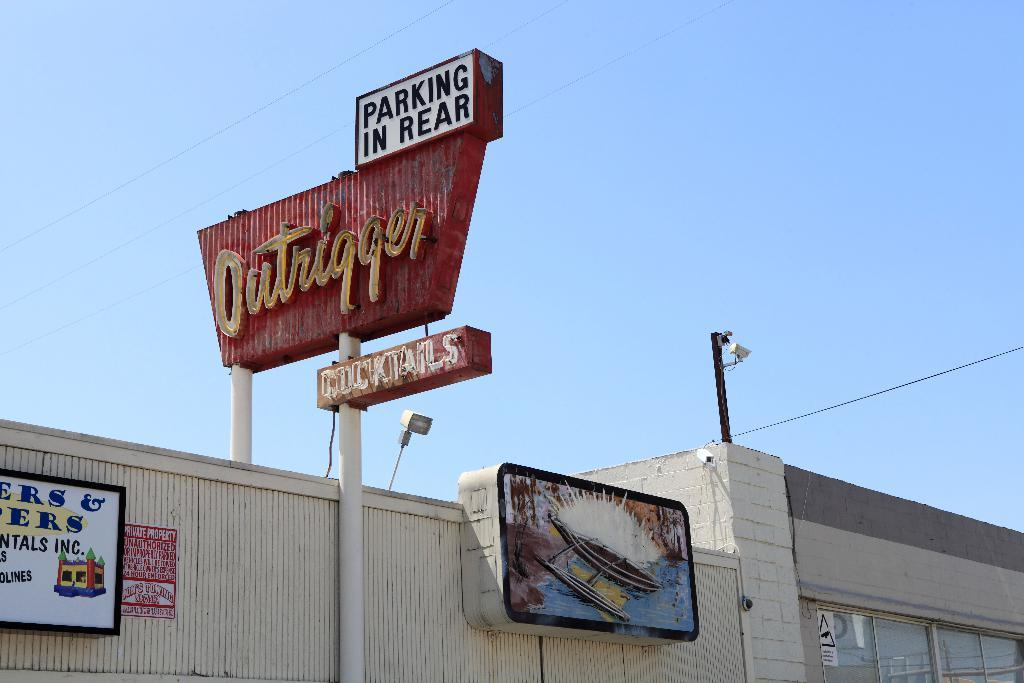<image>
Create a compact narrative representing the image presented. The Outrigger sign says that there is parking in the rear. 